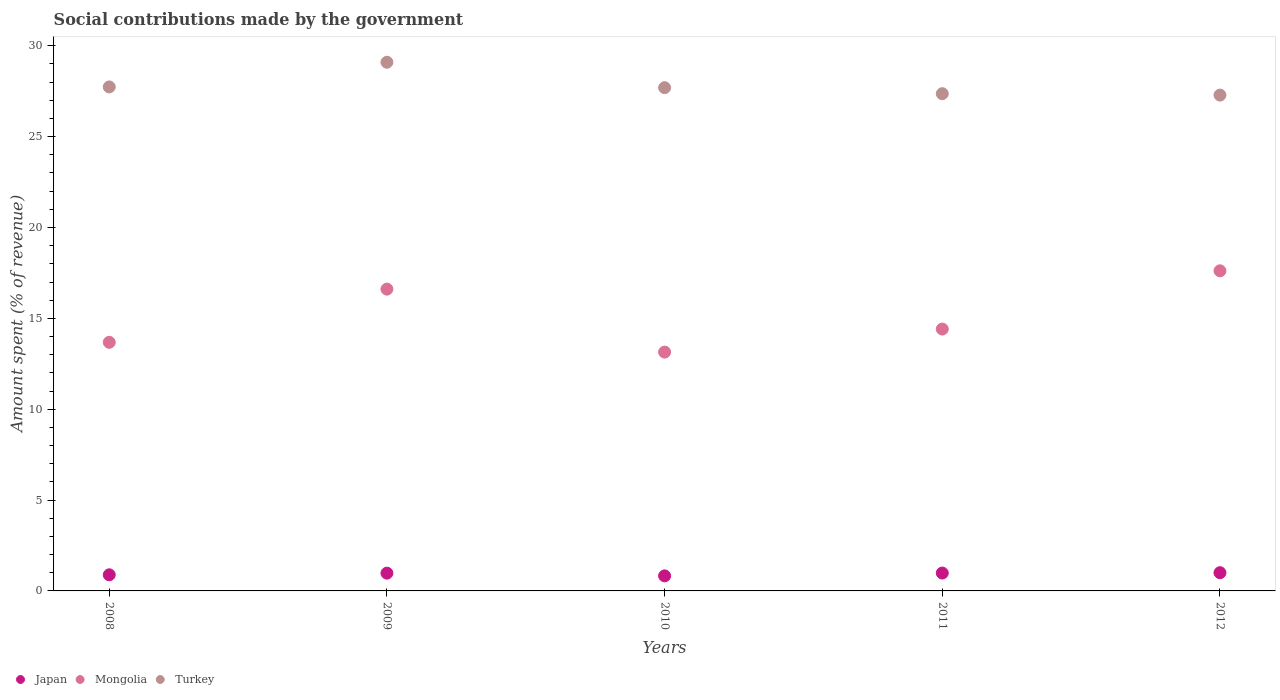How many different coloured dotlines are there?
Your response must be concise. 3. Is the number of dotlines equal to the number of legend labels?
Your response must be concise. Yes. What is the amount spent (in %) on social contributions in Mongolia in 2012?
Offer a very short reply. 17.62. Across all years, what is the maximum amount spent (in %) on social contributions in Japan?
Offer a terse response. 1. Across all years, what is the minimum amount spent (in %) on social contributions in Mongolia?
Your answer should be compact. 13.14. In which year was the amount spent (in %) on social contributions in Mongolia minimum?
Offer a terse response. 2010. What is the total amount spent (in %) on social contributions in Japan in the graph?
Provide a succinct answer. 4.68. What is the difference between the amount spent (in %) on social contributions in Turkey in 2009 and that in 2012?
Your answer should be compact. 1.81. What is the difference between the amount spent (in %) on social contributions in Turkey in 2008 and the amount spent (in %) on social contributions in Mongolia in 2009?
Your answer should be compact. 11.13. What is the average amount spent (in %) on social contributions in Turkey per year?
Offer a very short reply. 27.84. In the year 2012, what is the difference between the amount spent (in %) on social contributions in Mongolia and amount spent (in %) on social contributions in Japan?
Give a very brief answer. 16.61. What is the ratio of the amount spent (in %) on social contributions in Turkey in 2009 to that in 2011?
Your answer should be compact. 1.06. Is the difference between the amount spent (in %) on social contributions in Mongolia in 2011 and 2012 greater than the difference between the amount spent (in %) on social contributions in Japan in 2011 and 2012?
Offer a terse response. No. What is the difference between the highest and the second highest amount spent (in %) on social contributions in Turkey?
Provide a short and direct response. 1.36. What is the difference between the highest and the lowest amount spent (in %) on social contributions in Mongolia?
Make the answer very short. 4.47. Does the amount spent (in %) on social contributions in Japan monotonically increase over the years?
Make the answer very short. No. How many dotlines are there?
Your answer should be very brief. 3. Are the values on the major ticks of Y-axis written in scientific E-notation?
Your response must be concise. No. How are the legend labels stacked?
Your answer should be very brief. Horizontal. What is the title of the graph?
Your answer should be very brief. Social contributions made by the government. What is the label or title of the Y-axis?
Your answer should be very brief. Amount spent (% of revenue). What is the Amount spent (% of revenue) in Japan in 2008?
Your answer should be very brief. 0.89. What is the Amount spent (% of revenue) of Mongolia in 2008?
Offer a very short reply. 13.68. What is the Amount spent (% of revenue) of Turkey in 2008?
Provide a succinct answer. 27.74. What is the Amount spent (% of revenue) of Japan in 2009?
Your answer should be very brief. 0.98. What is the Amount spent (% of revenue) in Mongolia in 2009?
Keep it short and to the point. 16.61. What is the Amount spent (% of revenue) of Turkey in 2009?
Make the answer very short. 29.09. What is the Amount spent (% of revenue) of Japan in 2010?
Your answer should be compact. 0.83. What is the Amount spent (% of revenue) of Mongolia in 2010?
Your answer should be compact. 13.14. What is the Amount spent (% of revenue) in Turkey in 2010?
Ensure brevity in your answer.  27.7. What is the Amount spent (% of revenue) in Japan in 2011?
Provide a succinct answer. 0.98. What is the Amount spent (% of revenue) of Mongolia in 2011?
Your answer should be very brief. 14.41. What is the Amount spent (% of revenue) of Turkey in 2011?
Provide a succinct answer. 27.36. What is the Amount spent (% of revenue) of Japan in 2012?
Your answer should be compact. 1. What is the Amount spent (% of revenue) of Mongolia in 2012?
Ensure brevity in your answer.  17.62. What is the Amount spent (% of revenue) in Turkey in 2012?
Your answer should be compact. 27.29. Across all years, what is the maximum Amount spent (% of revenue) in Japan?
Provide a succinct answer. 1. Across all years, what is the maximum Amount spent (% of revenue) in Mongolia?
Provide a succinct answer. 17.62. Across all years, what is the maximum Amount spent (% of revenue) in Turkey?
Give a very brief answer. 29.09. Across all years, what is the minimum Amount spent (% of revenue) of Japan?
Your response must be concise. 0.83. Across all years, what is the minimum Amount spent (% of revenue) in Mongolia?
Provide a short and direct response. 13.14. Across all years, what is the minimum Amount spent (% of revenue) of Turkey?
Provide a short and direct response. 27.29. What is the total Amount spent (% of revenue) in Japan in the graph?
Your answer should be compact. 4.68. What is the total Amount spent (% of revenue) in Mongolia in the graph?
Give a very brief answer. 75.46. What is the total Amount spent (% of revenue) of Turkey in the graph?
Your answer should be very brief. 139.18. What is the difference between the Amount spent (% of revenue) of Japan in 2008 and that in 2009?
Ensure brevity in your answer.  -0.09. What is the difference between the Amount spent (% of revenue) of Mongolia in 2008 and that in 2009?
Your answer should be very brief. -2.93. What is the difference between the Amount spent (% of revenue) in Turkey in 2008 and that in 2009?
Give a very brief answer. -1.36. What is the difference between the Amount spent (% of revenue) of Japan in 2008 and that in 2010?
Ensure brevity in your answer.  0.06. What is the difference between the Amount spent (% of revenue) in Mongolia in 2008 and that in 2010?
Keep it short and to the point. 0.54. What is the difference between the Amount spent (% of revenue) in Turkey in 2008 and that in 2010?
Offer a very short reply. 0.04. What is the difference between the Amount spent (% of revenue) in Japan in 2008 and that in 2011?
Your answer should be very brief. -0.1. What is the difference between the Amount spent (% of revenue) of Mongolia in 2008 and that in 2011?
Your answer should be compact. -0.73. What is the difference between the Amount spent (% of revenue) of Turkey in 2008 and that in 2011?
Offer a terse response. 0.37. What is the difference between the Amount spent (% of revenue) in Japan in 2008 and that in 2012?
Give a very brief answer. -0.12. What is the difference between the Amount spent (% of revenue) in Mongolia in 2008 and that in 2012?
Make the answer very short. -3.94. What is the difference between the Amount spent (% of revenue) in Turkey in 2008 and that in 2012?
Your response must be concise. 0.45. What is the difference between the Amount spent (% of revenue) of Japan in 2009 and that in 2010?
Your answer should be compact. 0.15. What is the difference between the Amount spent (% of revenue) in Mongolia in 2009 and that in 2010?
Give a very brief answer. 3.47. What is the difference between the Amount spent (% of revenue) of Turkey in 2009 and that in 2010?
Offer a terse response. 1.4. What is the difference between the Amount spent (% of revenue) of Japan in 2009 and that in 2011?
Ensure brevity in your answer.  -0.01. What is the difference between the Amount spent (% of revenue) of Mongolia in 2009 and that in 2011?
Offer a very short reply. 2.2. What is the difference between the Amount spent (% of revenue) of Turkey in 2009 and that in 2011?
Offer a terse response. 1.73. What is the difference between the Amount spent (% of revenue) of Japan in 2009 and that in 2012?
Your response must be concise. -0.02. What is the difference between the Amount spent (% of revenue) of Mongolia in 2009 and that in 2012?
Provide a succinct answer. -1.01. What is the difference between the Amount spent (% of revenue) in Turkey in 2009 and that in 2012?
Keep it short and to the point. 1.81. What is the difference between the Amount spent (% of revenue) of Japan in 2010 and that in 2011?
Give a very brief answer. -0.16. What is the difference between the Amount spent (% of revenue) in Mongolia in 2010 and that in 2011?
Give a very brief answer. -1.27. What is the difference between the Amount spent (% of revenue) in Turkey in 2010 and that in 2011?
Keep it short and to the point. 0.33. What is the difference between the Amount spent (% of revenue) in Japan in 2010 and that in 2012?
Offer a very short reply. -0.17. What is the difference between the Amount spent (% of revenue) of Mongolia in 2010 and that in 2012?
Provide a succinct answer. -4.47. What is the difference between the Amount spent (% of revenue) of Turkey in 2010 and that in 2012?
Your response must be concise. 0.41. What is the difference between the Amount spent (% of revenue) in Japan in 2011 and that in 2012?
Your response must be concise. -0.02. What is the difference between the Amount spent (% of revenue) in Mongolia in 2011 and that in 2012?
Offer a terse response. -3.21. What is the difference between the Amount spent (% of revenue) in Turkey in 2011 and that in 2012?
Give a very brief answer. 0.08. What is the difference between the Amount spent (% of revenue) in Japan in 2008 and the Amount spent (% of revenue) in Mongolia in 2009?
Your answer should be compact. -15.72. What is the difference between the Amount spent (% of revenue) of Japan in 2008 and the Amount spent (% of revenue) of Turkey in 2009?
Ensure brevity in your answer.  -28.21. What is the difference between the Amount spent (% of revenue) in Mongolia in 2008 and the Amount spent (% of revenue) in Turkey in 2009?
Offer a terse response. -15.41. What is the difference between the Amount spent (% of revenue) of Japan in 2008 and the Amount spent (% of revenue) of Mongolia in 2010?
Your response must be concise. -12.26. What is the difference between the Amount spent (% of revenue) of Japan in 2008 and the Amount spent (% of revenue) of Turkey in 2010?
Your answer should be compact. -26.81. What is the difference between the Amount spent (% of revenue) in Mongolia in 2008 and the Amount spent (% of revenue) in Turkey in 2010?
Your response must be concise. -14.01. What is the difference between the Amount spent (% of revenue) in Japan in 2008 and the Amount spent (% of revenue) in Mongolia in 2011?
Ensure brevity in your answer.  -13.52. What is the difference between the Amount spent (% of revenue) of Japan in 2008 and the Amount spent (% of revenue) of Turkey in 2011?
Offer a terse response. -26.48. What is the difference between the Amount spent (% of revenue) in Mongolia in 2008 and the Amount spent (% of revenue) in Turkey in 2011?
Ensure brevity in your answer.  -13.68. What is the difference between the Amount spent (% of revenue) in Japan in 2008 and the Amount spent (% of revenue) in Mongolia in 2012?
Give a very brief answer. -16.73. What is the difference between the Amount spent (% of revenue) of Japan in 2008 and the Amount spent (% of revenue) of Turkey in 2012?
Provide a succinct answer. -26.4. What is the difference between the Amount spent (% of revenue) of Mongolia in 2008 and the Amount spent (% of revenue) of Turkey in 2012?
Offer a very short reply. -13.61. What is the difference between the Amount spent (% of revenue) of Japan in 2009 and the Amount spent (% of revenue) of Mongolia in 2010?
Keep it short and to the point. -12.16. What is the difference between the Amount spent (% of revenue) of Japan in 2009 and the Amount spent (% of revenue) of Turkey in 2010?
Your response must be concise. -26.72. What is the difference between the Amount spent (% of revenue) in Mongolia in 2009 and the Amount spent (% of revenue) in Turkey in 2010?
Offer a very short reply. -11.09. What is the difference between the Amount spent (% of revenue) in Japan in 2009 and the Amount spent (% of revenue) in Mongolia in 2011?
Your response must be concise. -13.43. What is the difference between the Amount spent (% of revenue) of Japan in 2009 and the Amount spent (% of revenue) of Turkey in 2011?
Offer a very short reply. -26.39. What is the difference between the Amount spent (% of revenue) of Mongolia in 2009 and the Amount spent (% of revenue) of Turkey in 2011?
Provide a succinct answer. -10.76. What is the difference between the Amount spent (% of revenue) of Japan in 2009 and the Amount spent (% of revenue) of Mongolia in 2012?
Offer a terse response. -16.64. What is the difference between the Amount spent (% of revenue) of Japan in 2009 and the Amount spent (% of revenue) of Turkey in 2012?
Your answer should be compact. -26.31. What is the difference between the Amount spent (% of revenue) in Mongolia in 2009 and the Amount spent (% of revenue) in Turkey in 2012?
Give a very brief answer. -10.68. What is the difference between the Amount spent (% of revenue) in Japan in 2010 and the Amount spent (% of revenue) in Mongolia in 2011?
Your answer should be compact. -13.58. What is the difference between the Amount spent (% of revenue) in Japan in 2010 and the Amount spent (% of revenue) in Turkey in 2011?
Keep it short and to the point. -26.54. What is the difference between the Amount spent (% of revenue) of Mongolia in 2010 and the Amount spent (% of revenue) of Turkey in 2011?
Your response must be concise. -14.22. What is the difference between the Amount spent (% of revenue) of Japan in 2010 and the Amount spent (% of revenue) of Mongolia in 2012?
Your answer should be compact. -16.79. What is the difference between the Amount spent (% of revenue) in Japan in 2010 and the Amount spent (% of revenue) in Turkey in 2012?
Give a very brief answer. -26.46. What is the difference between the Amount spent (% of revenue) of Mongolia in 2010 and the Amount spent (% of revenue) of Turkey in 2012?
Make the answer very short. -14.14. What is the difference between the Amount spent (% of revenue) of Japan in 2011 and the Amount spent (% of revenue) of Mongolia in 2012?
Your response must be concise. -16.63. What is the difference between the Amount spent (% of revenue) of Japan in 2011 and the Amount spent (% of revenue) of Turkey in 2012?
Keep it short and to the point. -26.3. What is the difference between the Amount spent (% of revenue) in Mongolia in 2011 and the Amount spent (% of revenue) in Turkey in 2012?
Provide a short and direct response. -12.88. What is the average Amount spent (% of revenue) of Japan per year?
Your response must be concise. 0.94. What is the average Amount spent (% of revenue) in Mongolia per year?
Give a very brief answer. 15.09. What is the average Amount spent (% of revenue) of Turkey per year?
Your response must be concise. 27.84. In the year 2008, what is the difference between the Amount spent (% of revenue) of Japan and Amount spent (% of revenue) of Mongolia?
Offer a terse response. -12.79. In the year 2008, what is the difference between the Amount spent (% of revenue) of Japan and Amount spent (% of revenue) of Turkey?
Your answer should be very brief. -26.85. In the year 2008, what is the difference between the Amount spent (% of revenue) in Mongolia and Amount spent (% of revenue) in Turkey?
Provide a succinct answer. -14.05. In the year 2009, what is the difference between the Amount spent (% of revenue) in Japan and Amount spent (% of revenue) in Mongolia?
Your response must be concise. -15.63. In the year 2009, what is the difference between the Amount spent (% of revenue) of Japan and Amount spent (% of revenue) of Turkey?
Offer a terse response. -28.12. In the year 2009, what is the difference between the Amount spent (% of revenue) in Mongolia and Amount spent (% of revenue) in Turkey?
Your answer should be very brief. -12.49. In the year 2010, what is the difference between the Amount spent (% of revenue) in Japan and Amount spent (% of revenue) in Mongolia?
Keep it short and to the point. -12.31. In the year 2010, what is the difference between the Amount spent (% of revenue) in Japan and Amount spent (% of revenue) in Turkey?
Ensure brevity in your answer.  -26.87. In the year 2010, what is the difference between the Amount spent (% of revenue) in Mongolia and Amount spent (% of revenue) in Turkey?
Make the answer very short. -14.55. In the year 2011, what is the difference between the Amount spent (% of revenue) in Japan and Amount spent (% of revenue) in Mongolia?
Your answer should be compact. -13.43. In the year 2011, what is the difference between the Amount spent (% of revenue) in Japan and Amount spent (% of revenue) in Turkey?
Keep it short and to the point. -26.38. In the year 2011, what is the difference between the Amount spent (% of revenue) in Mongolia and Amount spent (% of revenue) in Turkey?
Provide a succinct answer. -12.95. In the year 2012, what is the difference between the Amount spent (% of revenue) in Japan and Amount spent (% of revenue) in Mongolia?
Offer a very short reply. -16.61. In the year 2012, what is the difference between the Amount spent (% of revenue) in Japan and Amount spent (% of revenue) in Turkey?
Offer a very short reply. -26.28. In the year 2012, what is the difference between the Amount spent (% of revenue) in Mongolia and Amount spent (% of revenue) in Turkey?
Your response must be concise. -9.67. What is the ratio of the Amount spent (% of revenue) of Japan in 2008 to that in 2009?
Provide a succinct answer. 0.91. What is the ratio of the Amount spent (% of revenue) of Mongolia in 2008 to that in 2009?
Ensure brevity in your answer.  0.82. What is the ratio of the Amount spent (% of revenue) in Turkey in 2008 to that in 2009?
Provide a short and direct response. 0.95. What is the ratio of the Amount spent (% of revenue) in Japan in 2008 to that in 2010?
Your answer should be compact. 1.07. What is the ratio of the Amount spent (% of revenue) of Mongolia in 2008 to that in 2010?
Make the answer very short. 1.04. What is the ratio of the Amount spent (% of revenue) of Japan in 2008 to that in 2011?
Provide a short and direct response. 0.9. What is the ratio of the Amount spent (% of revenue) in Mongolia in 2008 to that in 2011?
Offer a terse response. 0.95. What is the ratio of the Amount spent (% of revenue) of Turkey in 2008 to that in 2011?
Make the answer very short. 1.01. What is the ratio of the Amount spent (% of revenue) of Japan in 2008 to that in 2012?
Your answer should be very brief. 0.89. What is the ratio of the Amount spent (% of revenue) in Mongolia in 2008 to that in 2012?
Give a very brief answer. 0.78. What is the ratio of the Amount spent (% of revenue) in Turkey in 2008 to that in 2012?
Your response must be concise. 1.02. What is the ratio of the Amount spent (% of revenue) in Japan in 2009 to that in 2010?
Your answer should be very brief. 1.18. What is the ratio of the Amount spent (% of revenue) in Mongolia in 2009 to that in 2010?
Provide a short and direct response. 1.26. What is the ratio of the Amount spent (% of revenue) in Turkey in 2009 to that in 2010?
Offer a terse response. 1.05. What is the ratio of the Amount spent (% of revenue) of Japan in 2009 to that in 2011?
Ensure brevity in your answer.  0.99. What is the ratio of the Amount spent (% of revenue) in Mongolia in 2009 to that in 2011?
Your answer should be very brief. 1.15. What is the ratio of the Amount spent (% of revenue) of Turkey in 2009 to that in 2011?
Your answer should be compact. 1.06. What is the ratio of the Amount spent (% of revenue) in Japan in 2009 to that in 2012?
Provide a succinct answer. 0.98. What is the ratio of the Amount spent (% of revenue) in Mongolia in 2009 to that in 2012?
Offer a terse response. 0.94. What is the ratio of the Amount spent (% of revenue) in Turkey in 2009 to that in 2012?
Offer a very short reply. 1.07. What is the ratio of the Amount spent (% of revenue) of Japan in 2010 to that in 2011?
Provide a succinct answer. 0.84. What is the ratio of the Amount spent (% of revenue) of Mongolia in 2010 to that in 2011?
Provide a short and direct response. 0.91. What is the ratio of the Amount spent (% of revenue) in Turkey in 2010 to that in 2011?
Keep it short and to the point. 1.01. What is the ratio of the Amount spent (% of revenue) in Japan in 2010 to that in 2012?
Make the answer very short. 0.83. What is the ratio of the Amount spent (% of revenue) in Mongolia in 2010 to that in 2012?
Provide a succinct answer. 0.75. What is the ratio of the Amount spent (% of revenue) of Japan in 2011 to that in 2012?
Keep it short and to the point. 0.98. What is the ratio of the Amount spent (% of revenue) of Mongolia in 2011 to that in 2012?
Give a very brief answer. 0.82. What is the difference between the highest and the second highest Amount spent (% of revenue) of Japan?
Your response must be concise. 0.02. What is the difference between the highest and the second highest Amount spent (% of revenue) of Turkey?
Provide a succinct answer. 1.36. What is the difference between the highest and the lowest Amount spent (% of revenue) of Japan?
Offer a very short reply. 0.17. What is the difference between the highest and the lowest Amount spent (% of revenue) in Mongolia?
Your answer should be compact. 4.47. What is the difference between the highest and the lowest Amount spent (% of revenue) in Turkey?
Your answer should be compact. 1.81. 